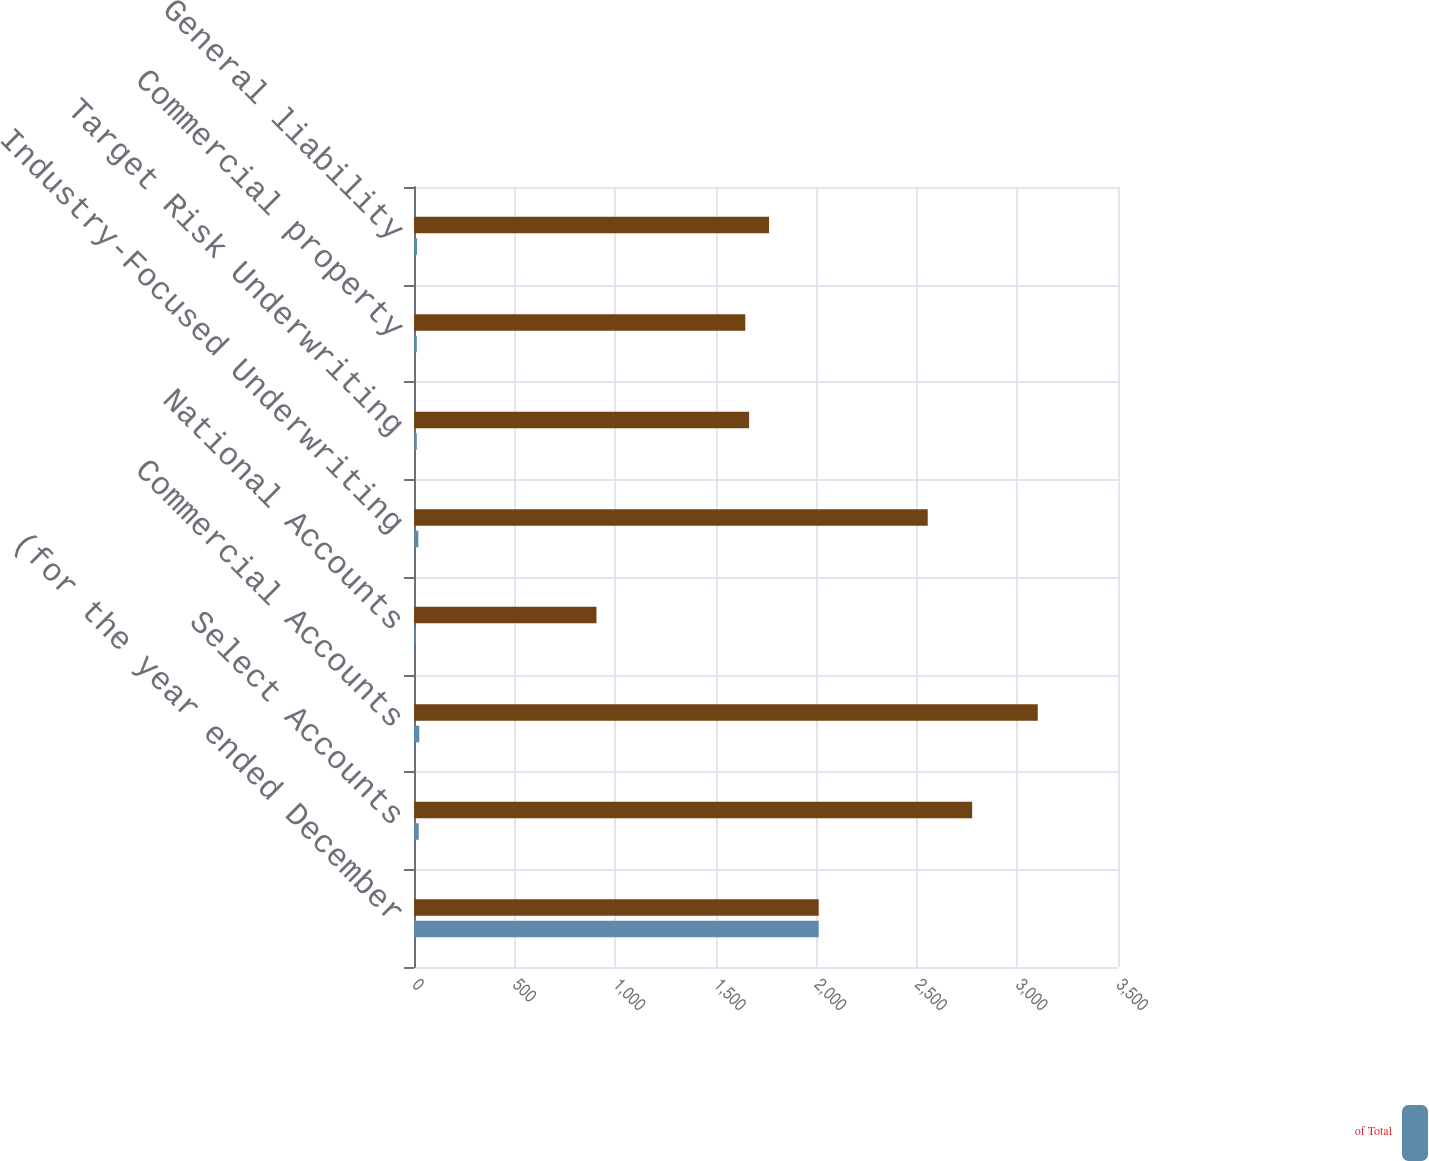<chart> <loc_0><loc_0><loc_500><loc_500><stacked_bar_chart><ecel><fcel>(for the year ended December<fcel>Select Accounts<fcel>Commercial Accounts<fcel>National Accounts<fcel>Industry-Focused Underwriting<fcel>Target Risk Underwriting<fcel>Commercial property<fcel>General liability<nl><fcel>nan<fcel>2012<fcel>2775<fcel>3101<fcel>907<fcel>2554<fcel>1666<fcel>1647<fcel>1765<nl><fcel>of Total<fcel>2012<fcel>23.4<fcel>26.1<fcel>7.7<fcel>21.5<fcel>14<fcel>13.9<fcel>14.9<nl></chart> 